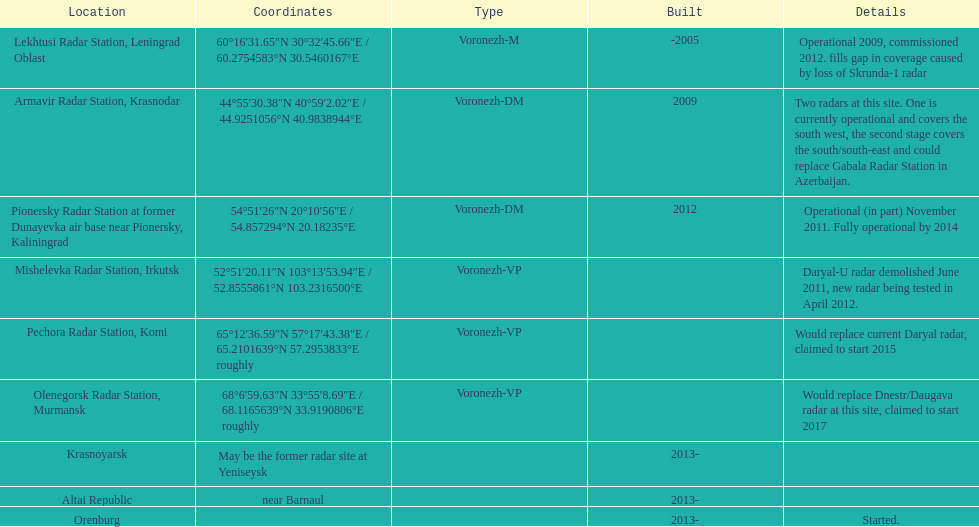How many voronezh radar systems were built up until 2010? 2. 